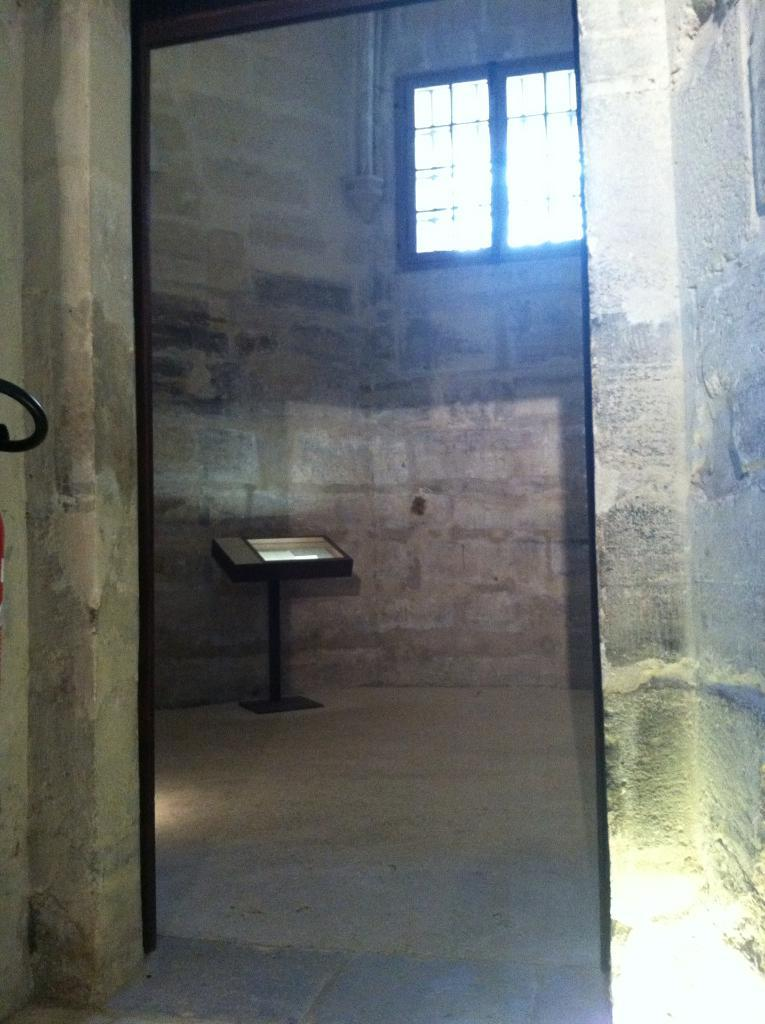What is the main object in the image? There is a board stand in the image. Where is the board stand located? The board stand is placed on the floor. What can be seen through the windows in the image? The presence of windows suggests that there is a view or scenery visible, but the specifics are not mentioned in the facts. What type of structure is visible in the image? The presence of a pipeline suggests that there might be some industrial or infrastructure-related elements in the image. What type of sea creatures can be seen swimming near the board stand in the image? There is no mention of a sea or any sea creatures in the image, so this question cannot be answered definitively. 